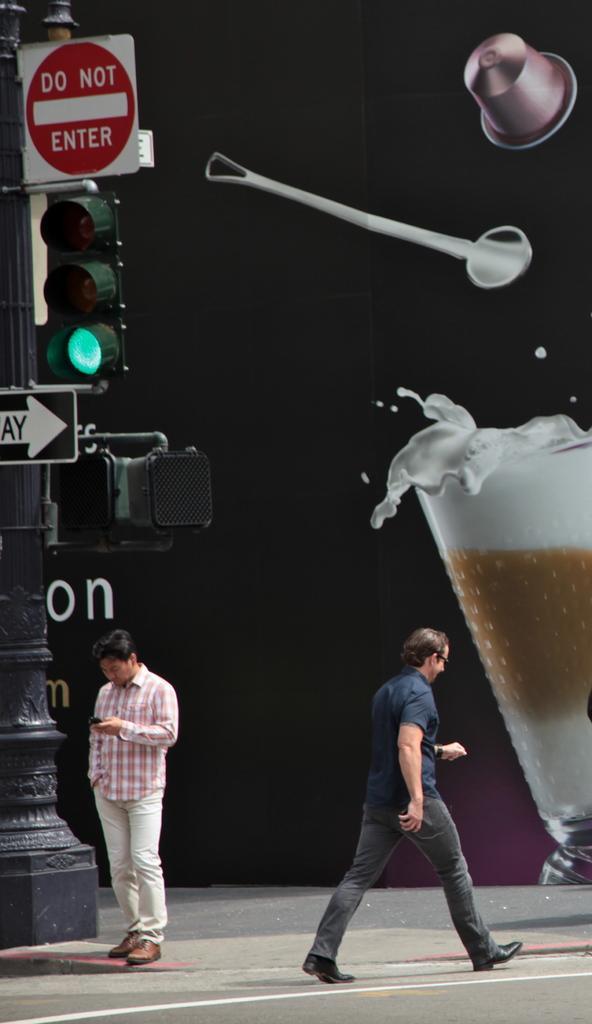Can you describe this image briefly? In the image there are two people walking on the road beside the street light pole, also there is a big banner where we can see there is a coffee cup, spoon and hat. 